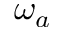Convert formula to latex. <formula><loc_0><loc_0><loc_500><loc_500>\omega _ { a }</formula> 